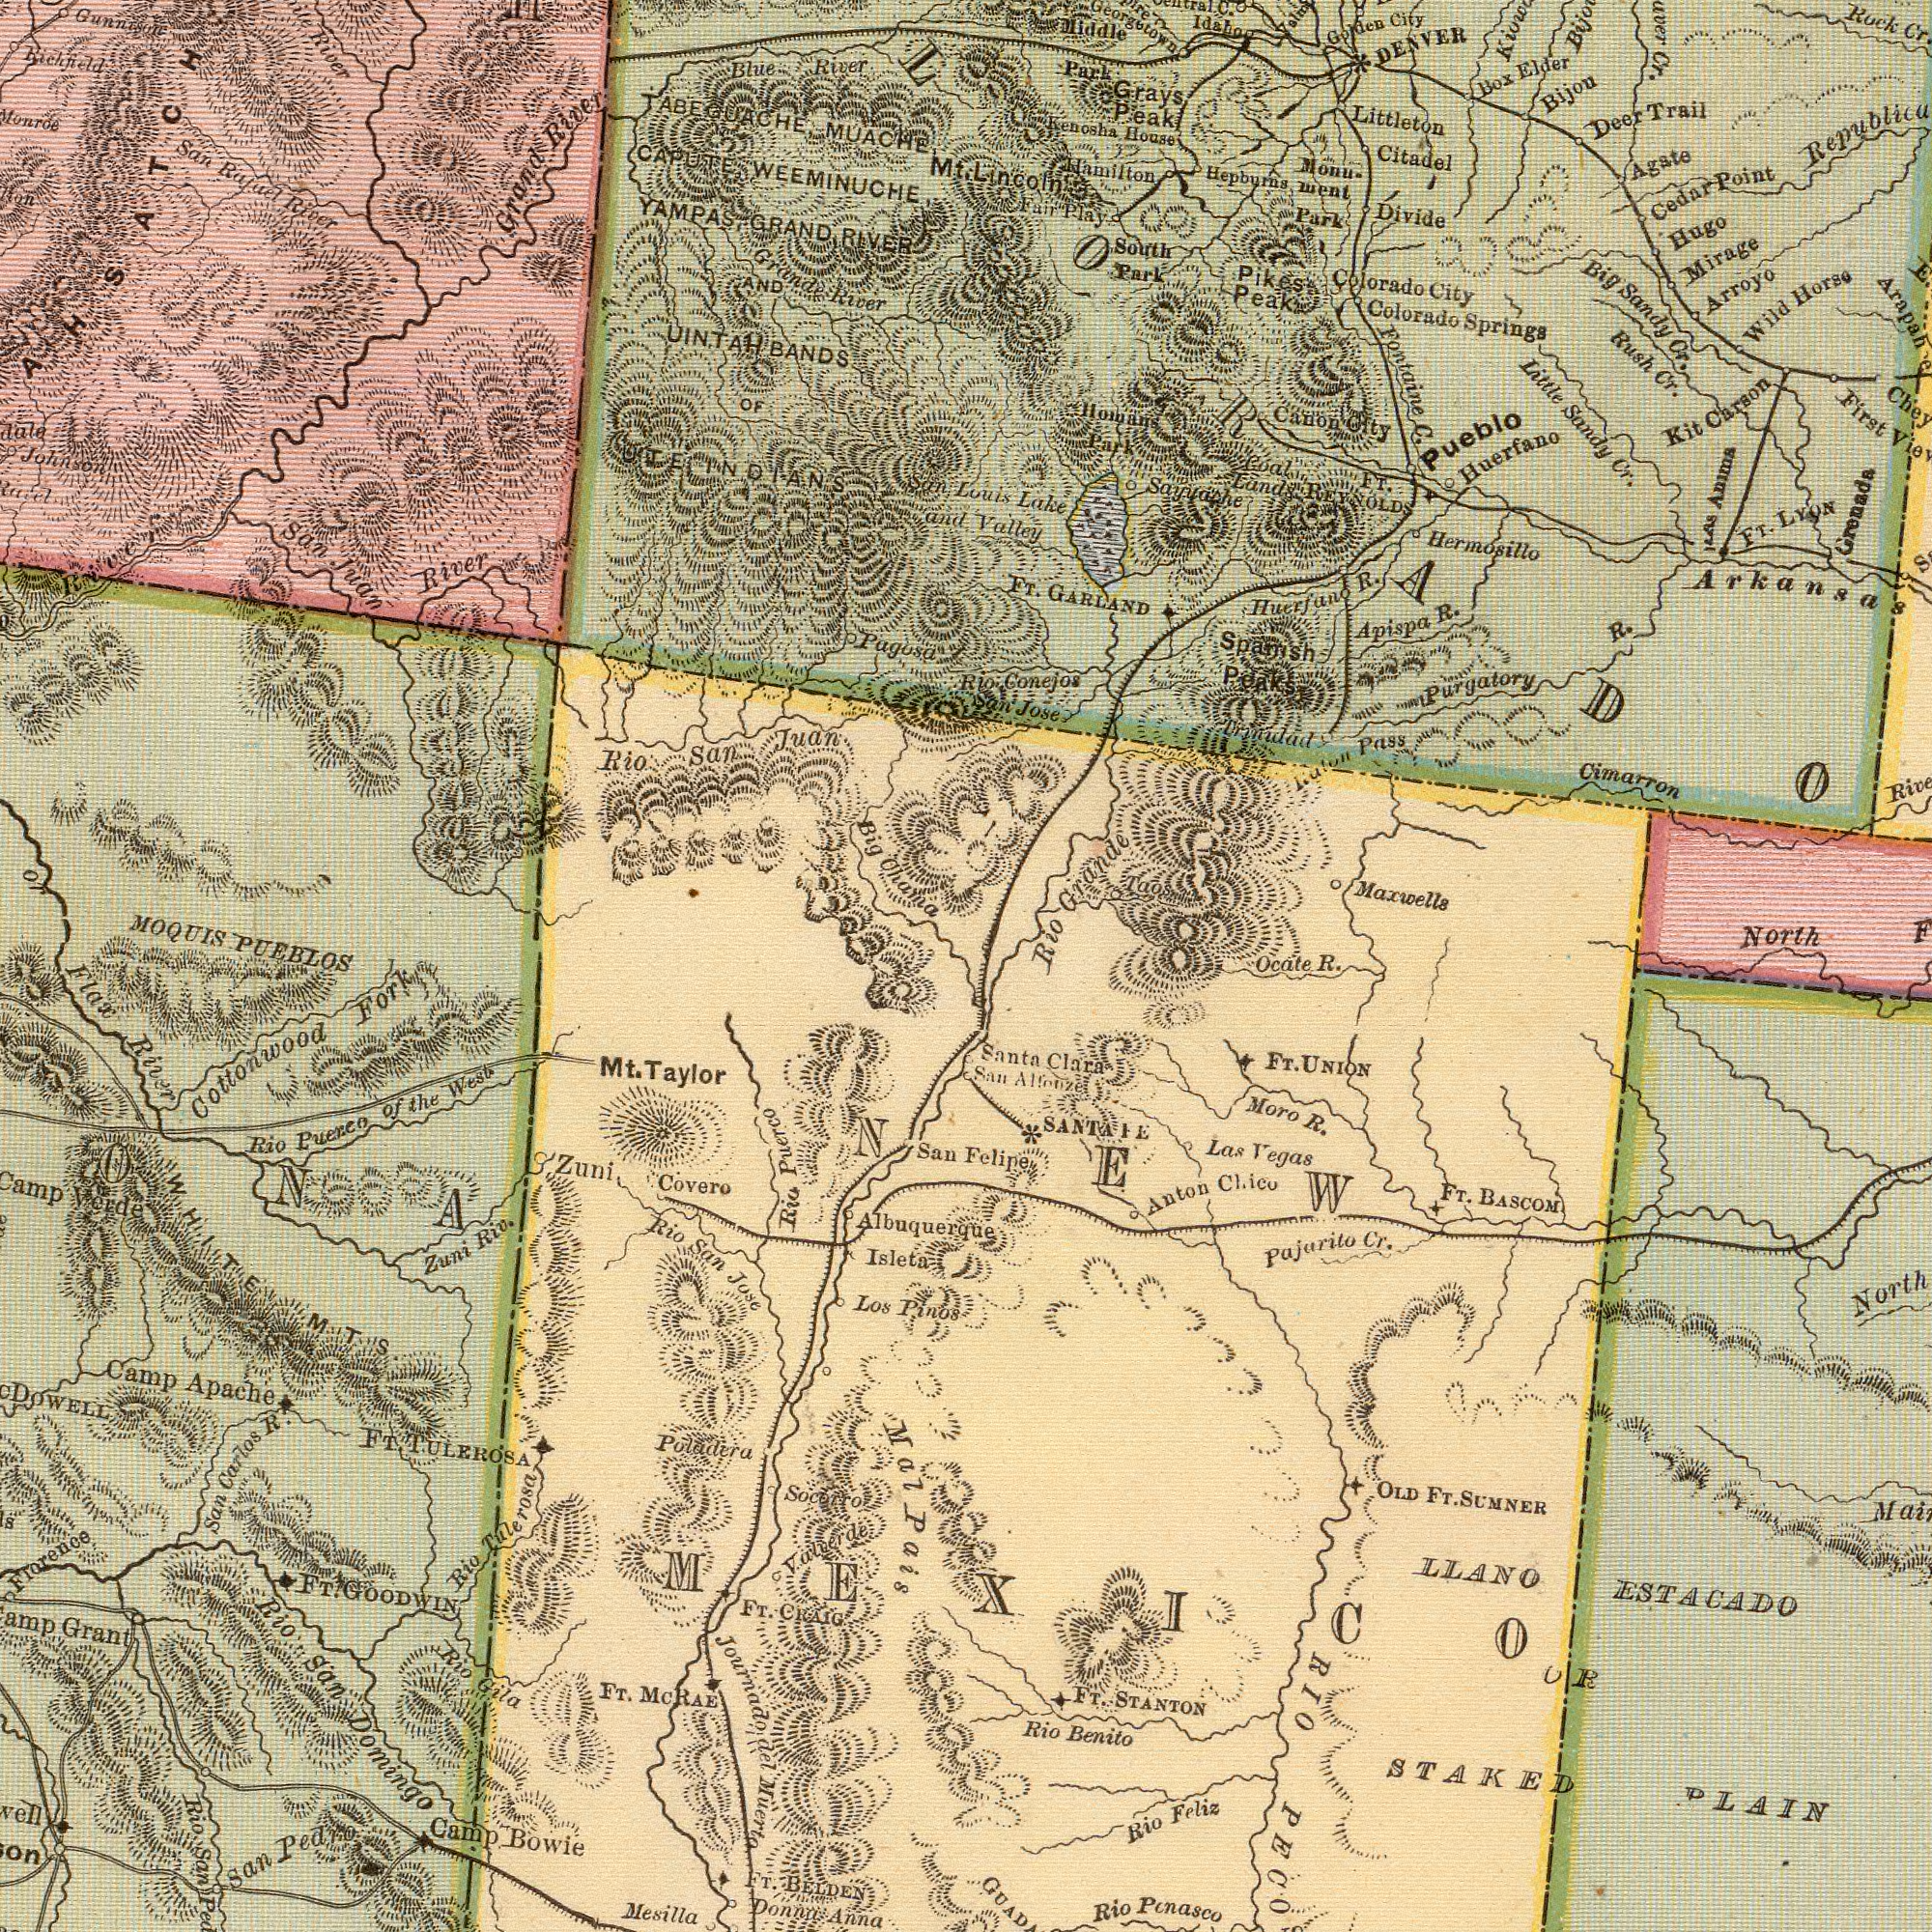What text can you see in the bottom-right section? LLANO STAKED Cr. FT. R. Ponasco Feliz Pajarito FT. PLAIN Clara BASCOM ESTACADO STANTON Benito FT. OLD Rio Santa Felipe Vegas Anton SUMNER UNION Moro RIO FT. icu Las Rio San SANTAFE Rio OR MEXICO CL. NEW What text appears in the bottom-left area of the image? Domingo Cottonwood Poladera R. Apache MC. Muerto Covero Verde Frorence Grant Flax Rio San Jose Rio Pinos San Rio Gila Mesilla Rio TULEROSA Puerco Riv. Pedro Taylor Donna Isleta San Fork Mt. Carlos Fr. Rio FT. BELDEN Rio Bowie Puerco DOWELL del Camp Zuni Pais Albuquerque San MTS of CRAIG Los Zuni Anna the River Camp FT. Rio Mai Journado Socorro WHITE FT. San GOODWIN San West FT. RAE Tulerosa ###ONA What text can you see in the top-right section? Cimarron Hermosillo Littleton GARLAND Horse Little Maxwells Huerfano Apispa Grenada Big Huerfan Arroyo Hepburns Crinidad Fontaine Bijon Box LYon Colorado Pass Mirage Rush Valley Springs Sandy FT. Cr. Deer R. Grande Hamilton DENVER Sandy Arkansas Conejos Jose Rock Kit Pikes Divide City Carson Cr. Lake Grays Lands Wild Park FT. South Rio R. Colorado Anima North Park Purgatory Agste Point Cr. Peak Peaks First Cr. Elder ment Louis City Middle Park Park Cedar House Idaho Rulun R. Pueblo Monu- Hugo Spanish Golden Play Citadel Taos Cr. Ocate R. Rio San ###LORADO FT. ###S REYNOLDS Coal C. Canon City Homans Fair Lincoln Trail Kenosha Peak C. What text can you see in the top-left section? WEEMINUCHE MUACHE River Rio Bichfield PUEBLOS MOQUIS RIVER River River CAPUTE River Juan River Blue BANDS River Grinde Johnson Ohama River Pagosa TABEGUACHE San YAMPAS Juan Grand GRAND Big Mt. Gunnison San OF Rafael AND INDIANS and San UINTAH San or ###TE 